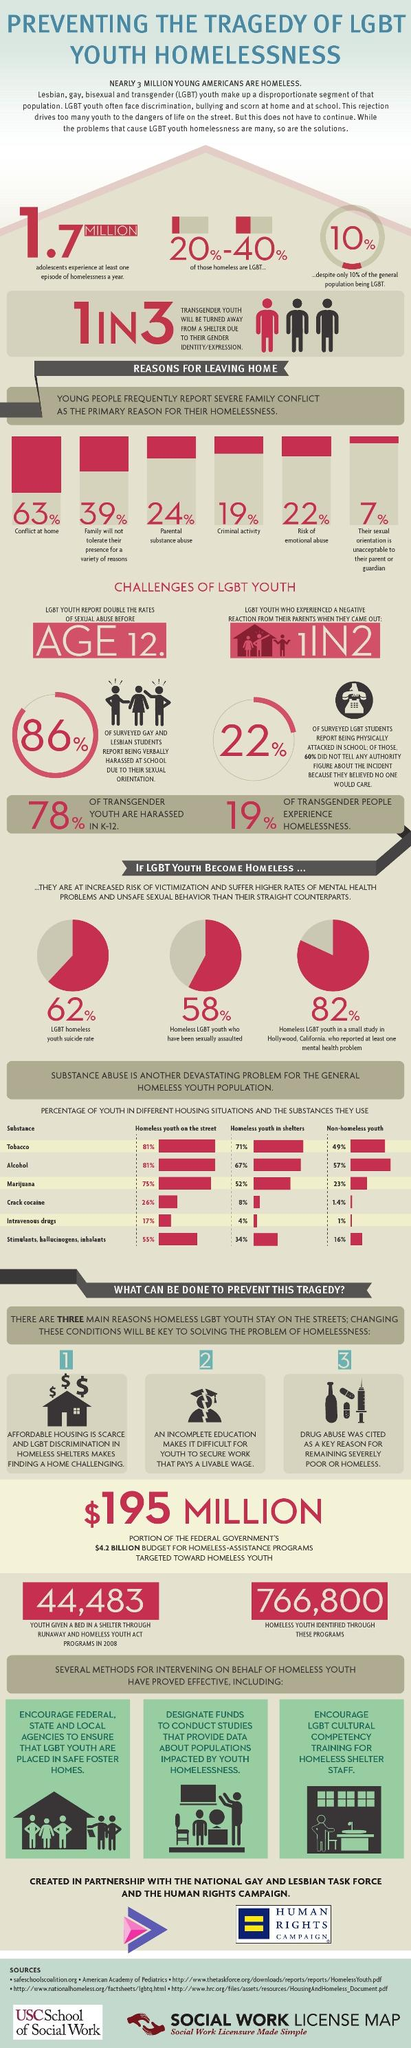Mention a couple of crucial points in this snapshot. According to a study conducted by the Ministry of Justice, 19% of young people leave home due to involvement in criminal activity. According to a study, approximately 22% of youth are at risk of experiencing emotional abuse. Drug abuse is a significant contributing factor in the persistent poverty and homelessness among young people. I am pleased to inform the honorable members of this esteemed chamber that the government has allocated a budget of $195 million for programs aimed at assisting homeless youth. The suicide rate among LGBT homeless youth is 62%. 